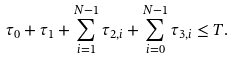Convert formula to latex. <formula><loc_0><loc_0><loc_500><loc_500>\tau _ { 0 } + \tau _ { 1 } + \sum ^ { N - 1 } _ { i = 1 } \tau _ { 2 , i } + \sum ^ { N - 1 } _ { i = 0 } \tau _ { 3 , i } \leq T . \\</formula> 